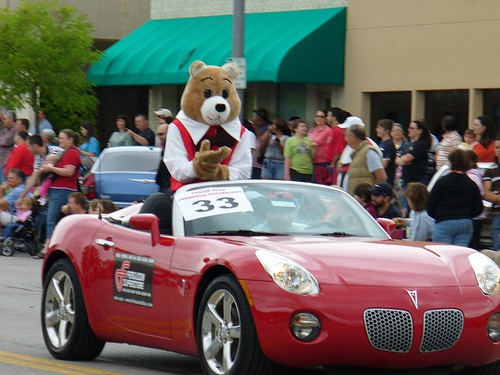Describe the objects in this image and their specific colors. I can see car in darkgray, black, lightgray, and maroon tones, people in darkgray, black, gray, brown, and maroon tones, teddy bear in darkgray, lightgray, gray, and maroon tones, people in darkgray, black, blue, navy, and gray tones, and car in darkgray and gray tones in this image. 